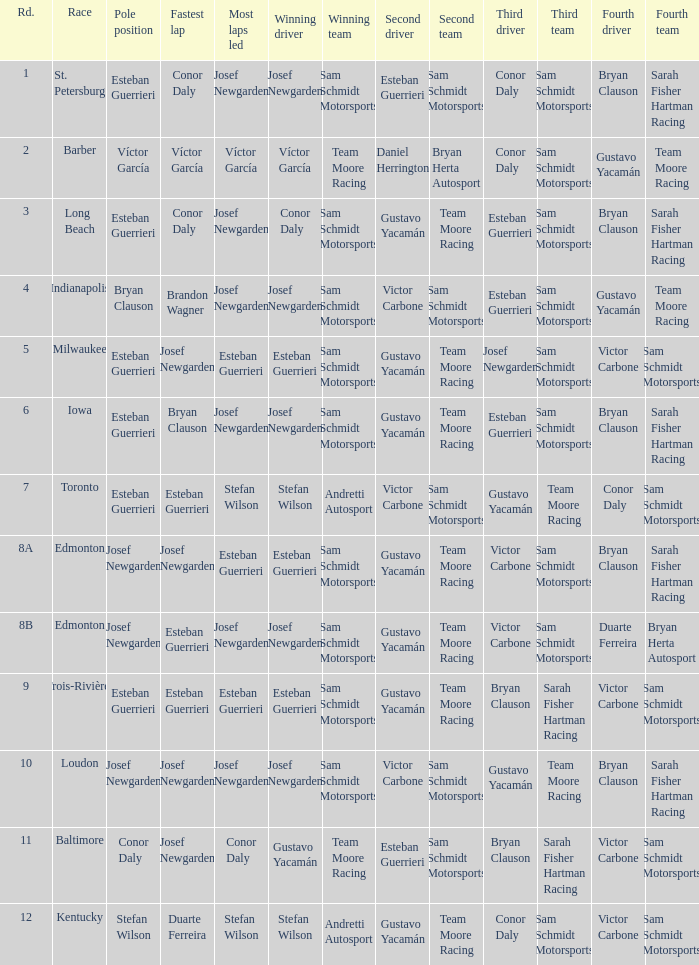What race did josef newgarden have the fastest lap and lead the most laps? Loudon. Would you mind parsing the complete table? {'header': ['Rd.', 'Race', 'Pole position', 'Fastest lap', 'Most laps led', 'Winning driver', 'Winning team', 'Second driver', 'Second team', 'Third driver', 'Third team', 'Fourth driver', 'Fourth team'], 'rows': [['1', 'St. Petersburg', 'Esteban Guerrieri', 'Conor Daly', 'Josef Newgarden', 'Josef Newgarden', 'Sam Schmidt Motorsports', 'Esteban Guerrieri', 'Sam Schmidt Motorsports', 'Conor Daly', 'Sam Schmidt Motorsports', 'Bryan Clauson', 'Sarah Fisher Hartman Racing'], ['2', 'Barber', 'Víctor García', 'Víctor García', 'Víctor García', 'Víctor García', 'Team Moore Racing', 'Daniel Herrington', 'Bryan Herta Autosport', 'Conor Daly', 'Sam Schmidt Motorsports', 'Gustavo Yacamán', 'Team Moore Racing'], ['3', 'Long Beach', 'Esteban Guerrieri', 'Conor Daly', 'Josef Newgarden', 'Conor Daly', 'Sam Schmidt Motorsports', 'Gustavo Yacamán', 'Team Moore Racing', 'Esteban Guerrieri', 'Sam Schmidt Motorsports', 'Bryan Clauson', 'Sarah Fisher Hartman Racing'], ['4', 'Indianapolis', 'Bryan Clauson', 'Brandon Wagner', 'Josef Newgarden', 'Josef Newgarden', 'Sam Schmidt Motorsports', 'Victor Carbone', 'Sam Schmidt Motorsports', 'Esteban Guerrieri', 'Sam Schmidt Motorsports', 'Gustavo Yacamán', 'Team Moore Racing'], ['5', 'Milwaukee', 'Esteban Guerrieri', 'Josef Newgarden', 'Esteban Guerrieri', 'Esteban Guerrieri', 'Sam Schmidt Motorsports', 'Gustavo Yacamán', 'Team Moore Racing', 'Josef Newgarden', 'Sam Schmidt Motorsports', 'Victor Carbone', 'Sam Schmidt Motorsports'], ['6', 'Iowa', 'Esteban Guerrieri', 'Bryan Clauson', 'Josef Newgarden', 'Josef Newgarden', 'Sam Schmidt Motorsports', 'Gustavo Yacamán', 'Team Moore Racing', 'Esteban Guerrieri', 'Sam Schmidt Motorsports', 'Bryan Clauson', 'Sarah Fisher Hartman Racing'], ['7', 'Toronto', 'Esteban Guerrieri', 'Esteban Guerrieri', 'Stefan Wilson', 'Stefan Wilson', 'Andretti Autosport', 'Victor Carbone', 'Sam Schmidt Motorsports', 'Gustavo Yacamán', 'Team Moore Racing', 'Conor Daly', 'Sam Schmidt Motorsports'], ['8A', 'Edmonton', 'Josef Newgarden', 'Josef Newgarden', 'Esteban Guerrieri', 'Esteban Guerrieri', 'Sam Schmidt Motorsports', 'Gustavo Yacamán', 'Team Moore Racing', 'Victor Carbone', 'Sam Schmidt Motorsports', 'Bryan Clauson', 'Sarah Fisher Hartman Racing'], ['8B', 'Edmonton', 'Josef Newgarden', 'Esteban Guerrieri', 'Josef Newgarden', 'Josef Newgarden', 'Sam Schmidt Motorsports', 'Gustavo Yacamán', 'Team Moore Racing', 'Victor Carbone', 'Sam Schmidt Motorsports', 'Duarte Ferreira', 'Bryan Herta Autosport'], ['9', 'Trois-Rivières', 'Esteban Guerrieri', 'Esteban Guerrieri', 'Esteban Guerrieri', 'Esteban Guerrieri', 'Sam Schmidt Motorsports', 'Gustavo Yacamán', 'Team Moore Racing', 'Bryan Clauson', 'Sarah Fisher Hartman Racing', 'Victor Carbone', 'Sam Schmidt Motorsports'], ['10', 'Loudon', 'Josef Newgarden', 'Josef Newgarden', 'Josef Newgarden', 'Josef Newgarden', 'Sam Schmidt Motorsports', 'Victor Carbone', 'Sam Schmidt Motorsports', 'Gustavo Yacamán', 'Team Moore Racing', 'Bryan Clauson', 'Sarah Fisher Hartman Racing'], ['11', 'Baltimore', 'Conor Daly', 'Josef Newgarden', 'Conor Daly', 'Gustavo Yacamán', 'Team Moore Racing', 'Esteban Guerrieri', 'Sam Schmidt Motorsports', 'Bryan Clauson', 'Sarah Fisher Hartman Racing', 'Victor Carbone', 'Sam Schmidt Motorsports'], ['12', 'Kentucky', 'Stefan Wilson', 'Duarte Ferreira', 'Stefan Wilson', 'Stefan Wilson', 'Andretti Autosport', 'Gustavo Yacamán', 'Team Moore Racing', 'Conor Daly', 'Sam Schmidt Motorsports', 'Victor Carbone', 'Sam Schmidt Motorsports']]} 